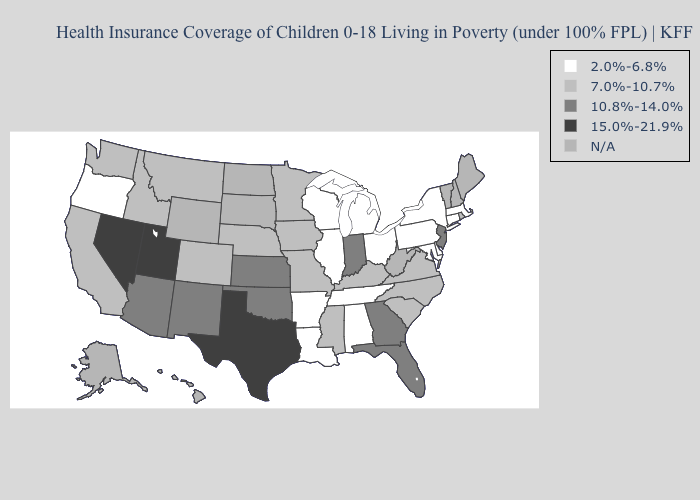Among the states that border Wyoming , which have the lowest value?
Quick response, please. Colorado, Idaho, Montana, Nebraska. Does the map have missing data?
Keep it brief. Yes. What is the lowest value in the MidWest?
Keep it brief. 2.0%-6.8%. What is the highest value in the Northeast ?
Answer briefly. 10.8%-14.0%. Name the states that have a value in the range 10.8%-14.0%?
Answer briefly. Arizona, Florida, Georgia, Indiana, Kansas, New Jersey, New Mexico, Oklahoma. What is the value of Alabama?
Be succinct. 2.0%-6.8%. How many symbols are there in the legend?
Answer briefly. 5. How many symbols are there in the legend?
Answer briefly. 5. Name the states that have a value in the range 2.0%-6.8%?
Be succinct. Alabama, Arkansas, Connecticut, Delaware, Illinois, Louisiana, Maryland, Massachusetts, Michigan, New York, Ohio, Oregon, Pennsylvania, Tennessee, Wisconsin. What is the value of Arkansas?
Concise answer only. 2.0%-6.8%. What is the value of Colorado?
Concise answer only. 7.0%-10.7%. What is the value of Florida?
Concise answer only. 10.8%-14.0%. 